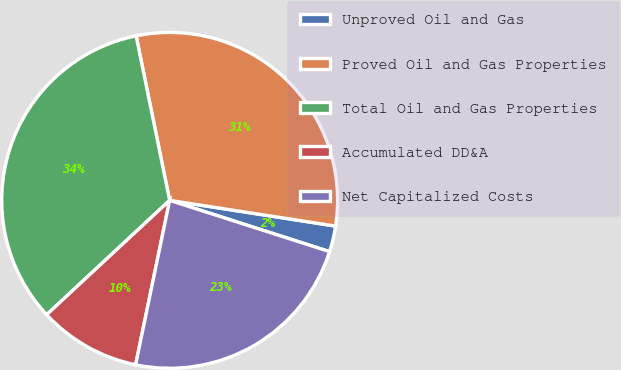Convert chart. <chart><loc_0><loc_0><loc_500><loc_500><pie_chart><fcel>Unproved Oil and Gas<fcel>Proved Oil and Gas Properties<fcel>Total Oil and Gas Properties<fcel>Accumulated DD&A<fcel>Net Capitalized Costs<nl><fcel>2.49%<fcel>30.65%<fcel>33.72%<fcel>9.83%<fcel>23.31%<nl></chart> 